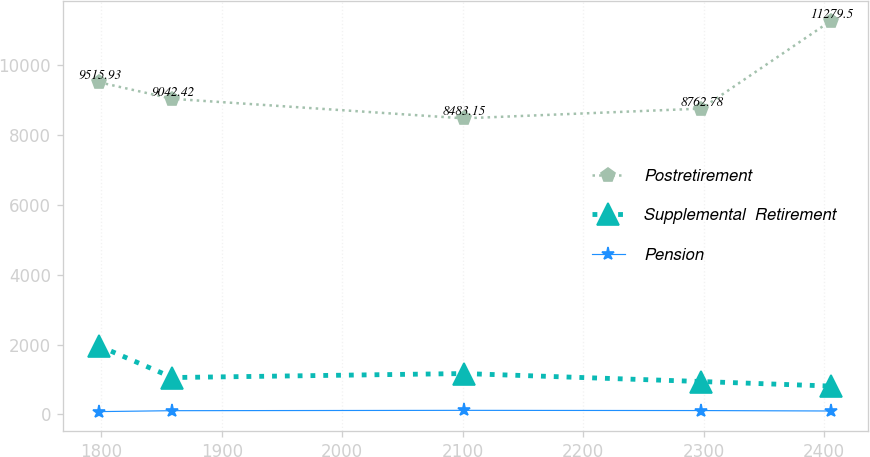Convert chart to OTSL. <chart><loc_0><loc_0><loc_500><loc_500><line_chart><ecel><fcel>Postretirement<fcel>Supplemental  Retirement<fcel>Pension<nl><fcel>1798.31<fcel>9515.93<fcel>1959.17<fcel>81.65<nl><fcel>1859.06<fcel>9042.42<fcel>1057.55<fcel>108.06<nl><fcel>2100.81<fcel>8483.15<fcel>1172.18<fcel>117.83<nl><fcel>2298.26<fcel>8762.78<fcel>942.92<fcel>111.68<nl><fcel>2405.81<fcel>11279.5<fcel>812.9<fcel>99.05<nl></chart> 